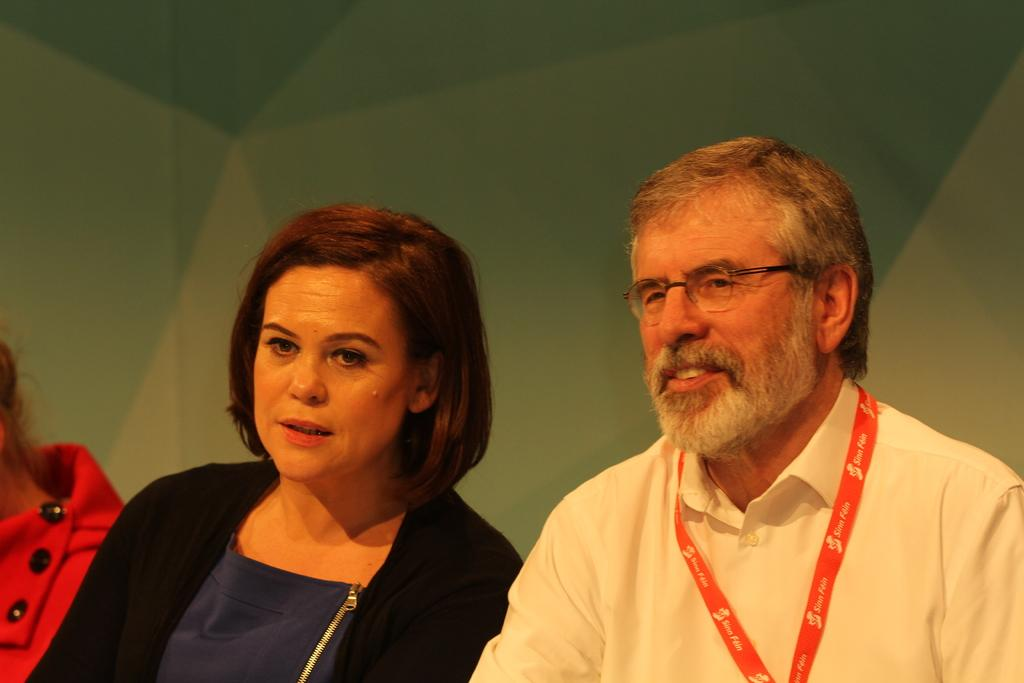What is the main subject of the image? There is a beautiful woman in the image. Where is the woman located in the image? The woman is in the middle of the image. What is the woman wearing? The woman is wearing a black coat. Who else is present in the image? There is a man in the image. Where is the man located in the image? The man is on the right side of the image. What is the man's facial expression? The man is smiling. What is the man wearing on his upper body? The man is wearing a white shirt. Does the man have any accessories in the image? Yes, the man is wearing spectacles. What type of sand can be seen on the woman's shoes in the image? There is no sand visible in the image, and the woman's shoes are not mentioned. What kind of rock is the man holding in the image? There is no rock present in the image; the man is not holding anything. 